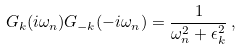<formula> <loc_0><loc_0><loc_500><loc_500>G _ { k } ( i \omega _ { n } ) G _ { - k } ( - i \omega _ { n } ) = \frac { 1 } { \omega _ { n } ^ { 2 } + \epsilon ^ { 2 } _ { k } } \, ,</formula> 